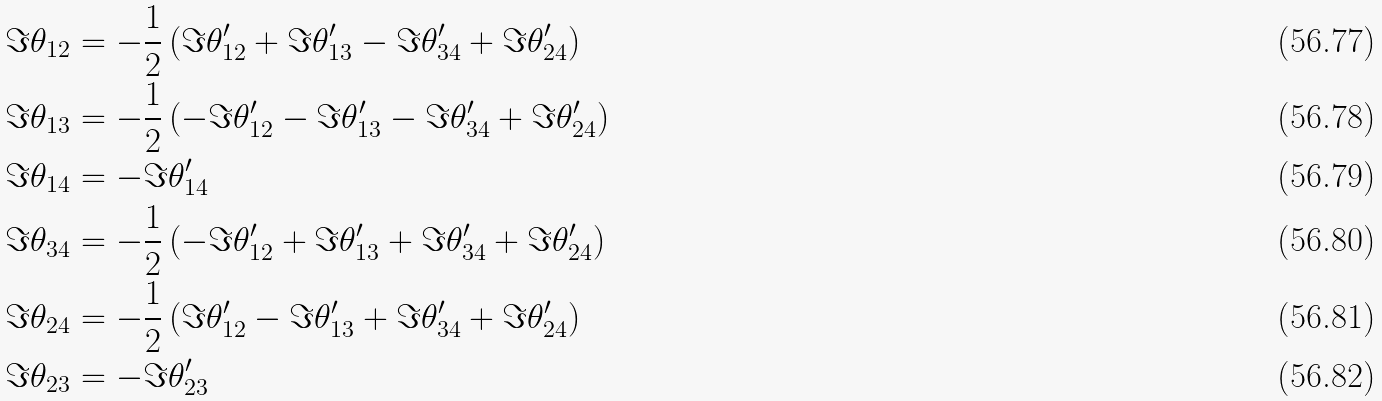Convert formula to latex. <formula><loc_0><loc_0><loc_500><loc_500>\Im \theta _ { 1 2 } & = - \frac { 1 } { 2 } \left ( \Im \theta _ { 1 2 } ^ { \prime } + \Im \theta _ { 1 3 } ^ { \prime } - \Im \theta _ { 3 4 } ^ { \prime } + \Im \theta _ { 2 4 } ^ { \prime } \right ) \\ \Im \theta _ { 1 3 } & = - \frac { 1 } { 2 } \left ( - \Im \theta _ { 1 2 } ^ { \prime } - \Im \theta _ { 1 3 } ^ { \prime } - \Im \theta _ { 3 4 } ^ { \prime } + \Im \theta _ { 2 4 } ^ { \prime } \right ) \\ \Im \theta _ { 1 4 } & = - \Im \theta _ { 1 4 } ^ { \prime } \\ \Im \theta _ { 3 4 } & = - \frac { 1 } { 2 } \left ( - \Im \theta _ { 1 2 } ^ { \prime } + \Im \theta _ { 1 3 } ^ { \prime } + \Im \theta _ { 3 4 } ^ { \prime } + \Im \theta _ { 2 4 } ^ { \prime } \right ) \\ \Im \theta _ { 2 4 } & = - \frac { 1 } { 2 } \left ( \Im \theta _ { 1 2 } ^ { \prime } - \Im \theta _ { 1 3 } ^ { \prime } + \Im \theta _ { 3 4 } ^ { \prime } + \Im \theta _ { 2 4 } ^ { \prime } \right ) \\ \Im \theta _ { 2 3 } & = - \Im \theta _ { 2 3 } ^ { \prime }</formula> 